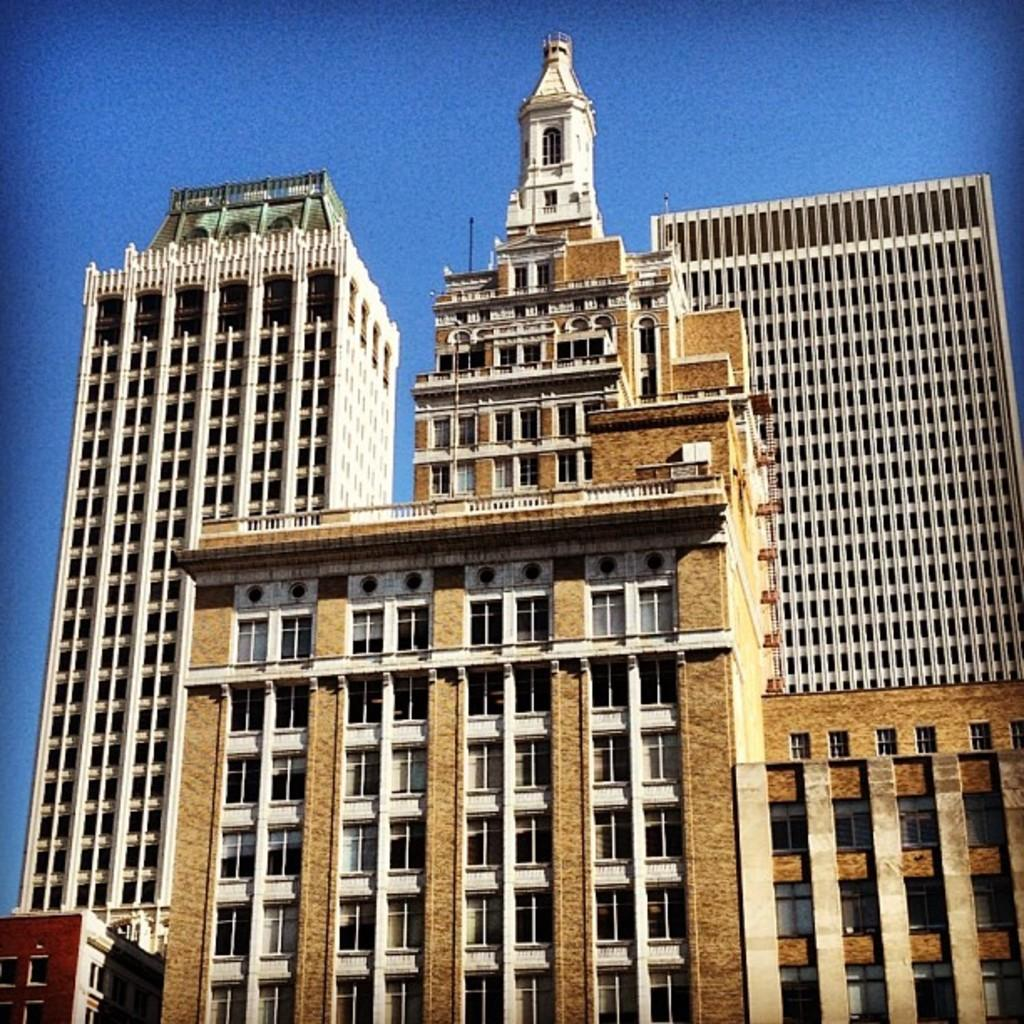Where was the image taken? The image was taken outdoors. What can be seen in the background of the image? The sky is visible in the background of the image. What structures are present in the middle of the image? There are buildings in the middle of the image. What are some features of the buildings? The buildings have walls, windows, doors, railings, balconies, and roofs. What type of mark can be seen on the cave in the image? There is no cave present in the image; it features buildings with various features. What shape is the cave in the image? There is no cave present in the image, so it is not possible to determine its shape. 